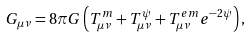<formula> <loc_0><loc_0><loc_500><loc_500>G _ { \mu \nu } = 8 \pi G \left ( T _ { \mu \nu } ^ { m } + T _ { \mu \nu } ^ { \psi } + T _ { \mu \nu } ^ { e m } e ^ { - 2 \psi } \right ) ,</formula> 